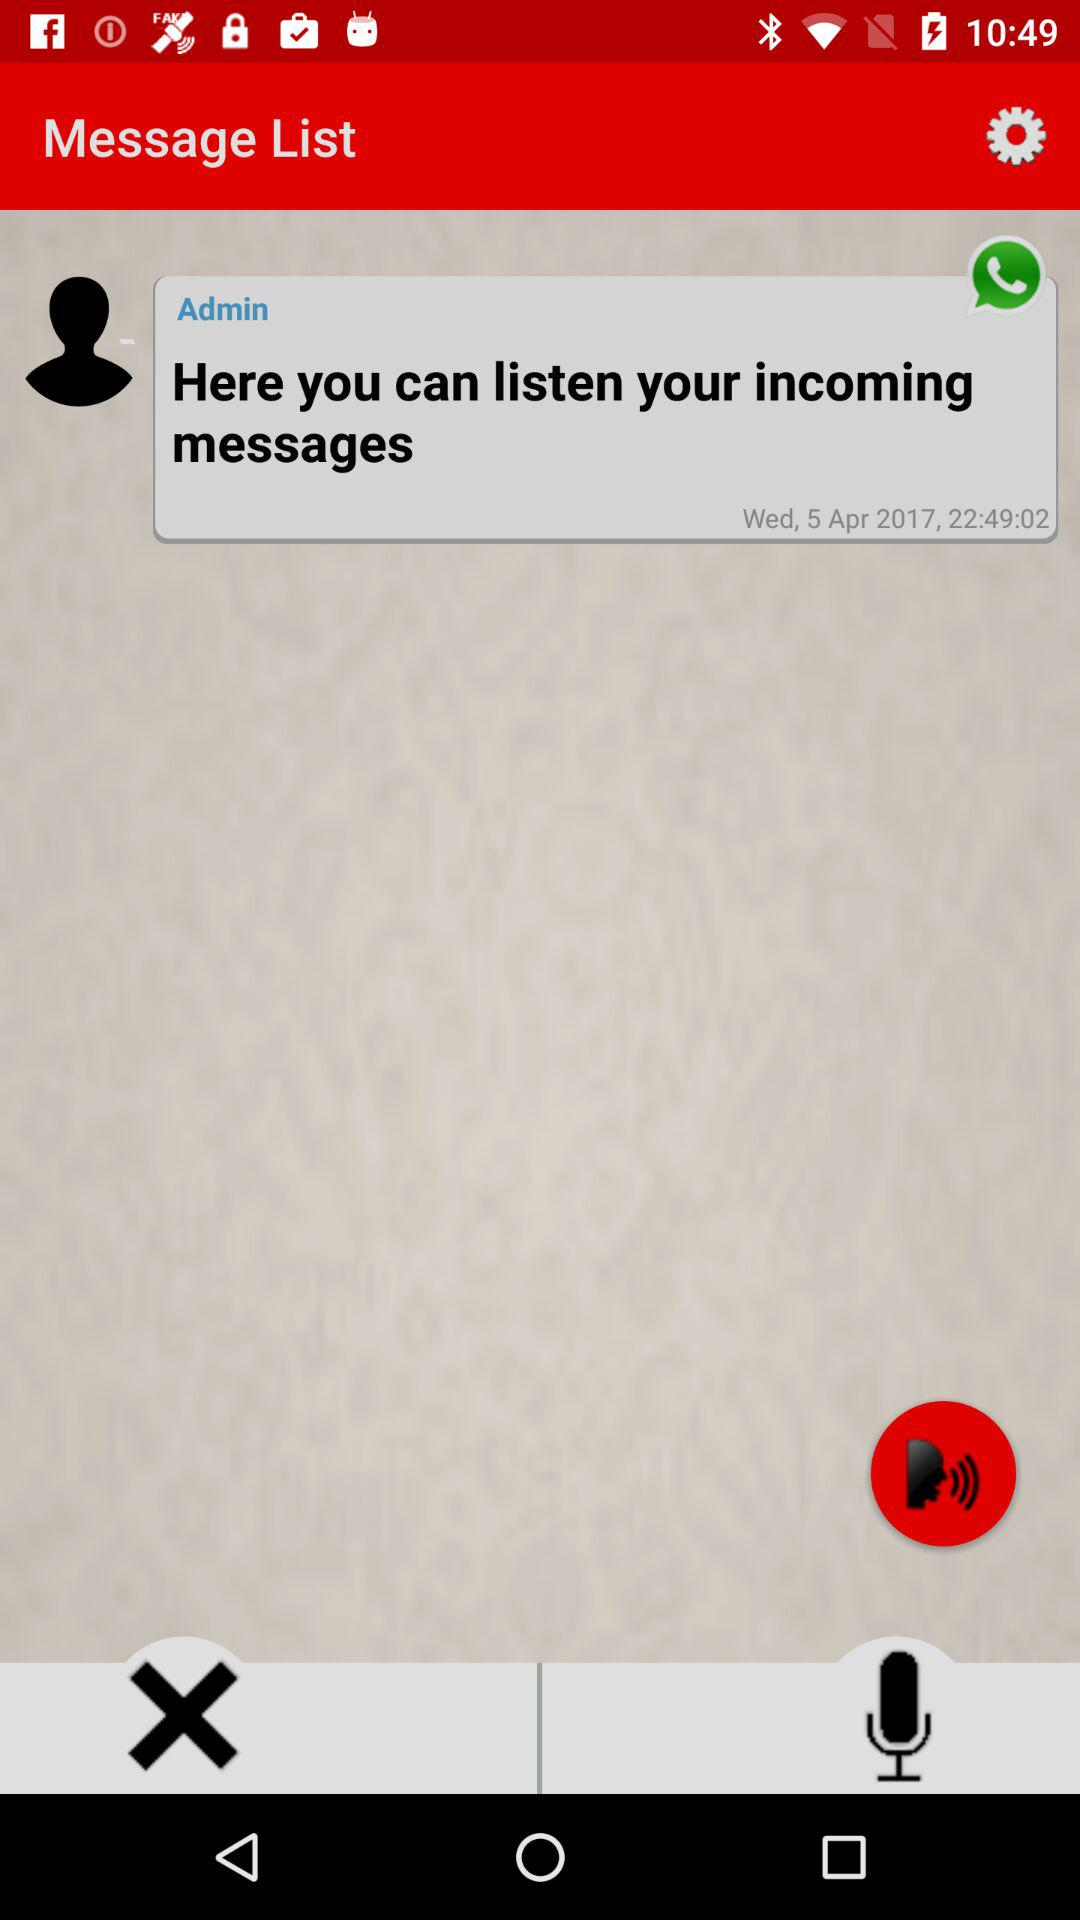Who has sent the message? The message was sent by Admin. 